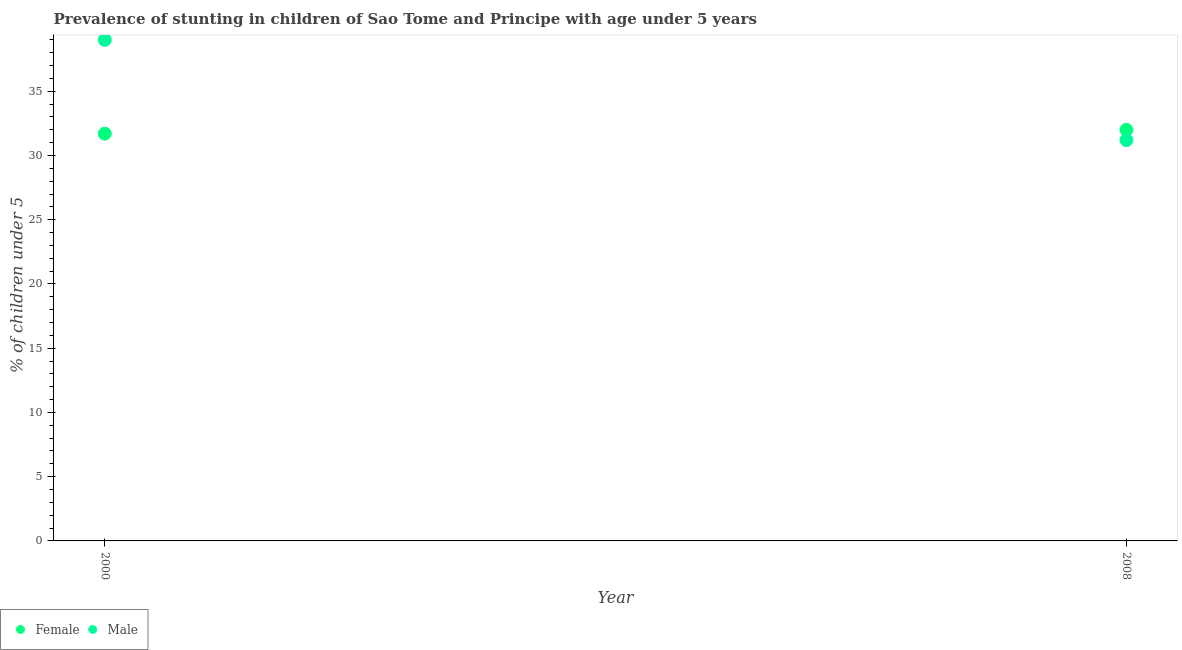What is the percentage of stunted male children in 2008?
Provide a succinct answer. 31.2. Across all years, what is the maximum percentage of stunted male children?
Your response must be concise. 39. Across all years, what is the minimum percentage of stunted female children?
Provide a short and direct response. 31.7. In which year was the percentage of stunted male children minimum?
Offer a terse response. 2008. What is the total percentage of stunted male children in the graph?
Make the answer very short. 70.2. What is the difference between the percentage of stunted female children in 2000 and that in 2008?
Make the answer very short. -0.3. What is the average percentage of stunted male children per year?
Provide a short and direct response. 35.1. In the year 2000, what is the difference between the percentage of stunted male children and percentage of stunted female children?
Keep it short and to the point. 7.3. In how many years, is the percentage of stunted female children greater than 14 %?
Keep it short and to the point. 2. What is the ratio of the percentage of stunted female children in 2000 to that in 2008?
Offer a terse response. 0.99. In how many years, is the percentage of stunted male children greater than the average percentage of stunted male children taken over all years?
Provide a succinct answer. 1. Is the percentage of stunted female children strictly greater than the percentage of stunted male children over the years?
Your answer should be compact. No. How many dotlines are there?
Give a very brief answer. 2. How many years are there in the graph?
Keep it short and to the point. 2. What is the difference between two consecutive major ticks on the Y-axis?
Your answer should be compact. 5. Are the values on the major ticks of Y-axis written in scientific E-notation?
Offer a terse response. No. Does the graph contain grids?
Your answer should be very brief. No. Where does the legend appear in the graph?
Give a very brief answer. Bottom left. How many legend labels are there?
Offer a terse response. 2. How are the legend labels stacked?
Your response must be concise. Horizontal. What is the title of the graph?
Ensure brevity in your answer.  Prevalence of stunting in children of Sao Tome and Principe with age under 5 years. Does "Mineral" appear as one of the legend labels in the graph?
Make the answer very short. No. What is the label or title of the Y-axis?
Your response must be concise.  % of children under 5. What is the  % of children under 5 in Female in 2000?
Make the answer very short. 31.7. What is the  % of children under 5 of Male in 2008?
Your answer should be compact. 31.2. Across all years, what is the maximum  % of children under 5 in Female?
Your answer should be very brief. 32. Across all years, what is the maximum  % of children under 5 in Male?
Provide a short and direct response. 39. Across all years, what is the minimum  % of children under 5 in Female?
Ensure brevity in your answer.  31.7. Across all years, what is the minimum  % of children under 5 in Male?
Offer a terse response. 31.2. What is the total  % of children under 5 in Female in the graph?
Make the answer very short. 63.7. What is the total  % of children under 5 in Male in the graph?
Provide a short and direct response. 70.2. What is the average  % of children under 5 of Female per year?
Offer a very short reply. 31.85. What is the average  % of children under 5 of Male per year?
Your answer should be very brief. 35.1. In the year 2000, what is the difference between the  % of children under 5 of Female and  % of children under 5 of Male?
Offer a very short reply. -7.3. In the year 2008, what is the difference between the  % of children under 5 of Female and  % of children under 5 of Male?
Offer a very short reply. 0.8. What is the ratio of the  % of children under 5 in Female in 2000 to that in 2008?
Offer a terse response. 0.99. What is the difference between the highest and the second highest  % of children under 5 of Female?
Provide a succinct answer. 0.3. What is the difference between the highest and the lowest  % of children under 5 of Male?
Your answer should be very brief. 7.8. 